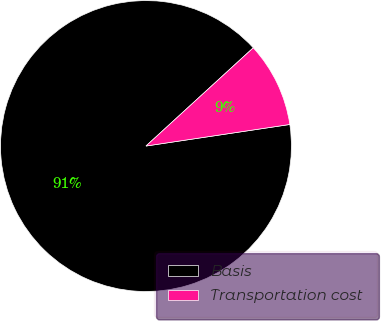<chart> <loc_0><loc_0><loc_500><loc_500><pie_chart><fcel>Basis<fcel>Transportation cost<nl><fcel>90.57%<fcel>9.43%<nl></chart> 